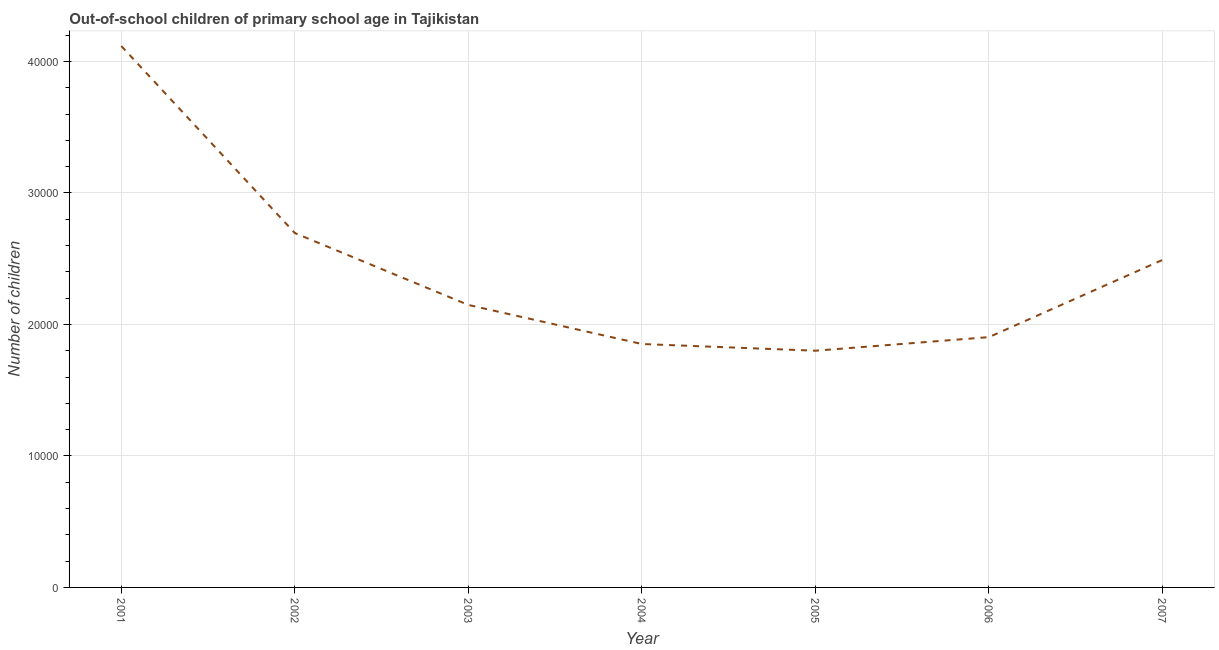What is the number of out-of-school children in 2006?
Offer a terse response. 1.90e+04. Across all years, what is the maximum number of out-of-school children?
Your response must be concise. 4.12e+04. Across all years, what is the minimum number of out-of-school children?
Your answer should be compact. 1.80e+04. In which year was the number of out-of-school children maximum?
Your answer should be compact. 2001. What is the sum of the number of out-of-school children?
Provide a succinct answer. 1.70e+05. What is the difference between the number of out-of-school children in 2005 and 2006?
Your response must be concise. -1034. What is the average number of out-of-school children per year?
Make the answer very short. 2.43e+04. What is the median number of out-of-school children?
Provide a short and direct response. 2.15e+04. In how many years, is the number of out-of-school children greater than 16000 ?
Offer a very short reply. 7. What is the ratio of the number of out-of-school children in 2001 to that in 2004?
Keep it short and to the point. 2.22. Is the difference between the number of out-of-school children in 2001 and 2002 greater than the difference between any two years?
Your answer should be very brief. No. What is the difference between the highest and the second highest number of out-of-school children?
Your answer should be compact. 1.42e+04. Is the sum of the number of out-of-school children in 2006 and 2007 greater than the maximum number of out-of-school children across all years?
Your response must be concise. Yes. What is the difference between the highest and the lowest number of out-of-school children?
Offer a very short reply. 2.32e+04. Does the number of out-of-school children monotonically increase over the years?
Provide a short and direct response. No. How many years are there in the graph?
Provide a short and direct response. 7. Are the values on the major ticks of Y-axis written in scientific E-notation?
Ensure brevity in your answer.  No. Does the graph contain grids?
Give a very brief answer. Yes. What is the title of the graph?
Keep it short and to the point. Out-of-school children of primary school age in Tajikistan. What is the label or title of the X-axis?
Offer a very short reply. Year. What is the label or title of the Y-axis?
Your response must be concise. Number of children. What is the Number of children in 2001?
Your response must be concise. 4.12e+04. What is the Number of children of 2002?
Your answer should be very brief. 2.69e+04. What is the Number of children of 2003?
Ensure brevity in your answer.  2.15e+04. What is the Number of children of 2004?
Give a very brief answer. 1.85e+04. What is the Number of children in 2005?
Your answer should be very brief. 1.80e+04. What is the Number of children of 2006?
Provide a short and direct response. 1.90e+04. What is the Number of children of 2007?
Your answer should be compact. 2.49e+04. What is the difference between the Number of children in 2001 and 2002?
Your answer should be very brief. 1.42e+04. What is the difference between the Number of children in 2001 and 2003?
Provide a succinct answer. 1.97e+04. What is the difference between the Number of children in 2001 and 2004?
Provide a succinct answer. 2.27e+04. What is the difference between the Number of children in 2001 and 2005?
Your answer should be compact. 2.32e+04. What is the difference between the Number of children in 2001 and 2006?
Offer a terse response. 2.21e+04. What is the difference between the Number of children in 2001 and 2007?
Make the answer very short. 1.63e+04. What is the difference between the Number of children in 2002 and 2003?
Offer a very short reply. 5466. What is the difference between the Number of children in 2002 and 2004?
Provide a short and direct response. 8435. What is the difference between the Number of children in 2002 and 2005?
Ensure brevity in your answer.  8945. What is the difference between the Number of children in 2002 and 2006?
Your answer should be compact. 7911. What is the difference between the Number of children in 2002 and 2007?
Your answer should be very brief. 2042. What is the difference between the Number of children in 2003 and 2004?
Your answer should be compact. 2969. What is the difference between the Number of children in 2003 and 2005?
Your response must be concise. 3479. What is the difference between the Number of children in 2003 and 2006?
Your response must be concise. 2445. What is the difference between the Number of children in 2003 and 2007?
Offer a very short reply. -3424. What is the difference between the Number of children in 2004 and 2005?
Make the answer very short. 510. What is the difference between the Number of children in 2004 and 2006?
Ensure brevity in your answer.  -524. What is the difference between the Number of children in 2004 and 2007?
Make the answer very short. -6393. What is the difference between the Number of children in 2005 and 2006?
Provide a short and direct response. -1034. What is the difference between the Number of children in 2005 and 2007?
Your answer should be very brief. -6903. What is the difference between the Number of children in 2006 and 2007?
Ensure brevity in your answer.  -5869. What is the ratio of the Number of children in 2001 to that in 2002?
Offer a very short reply. 1.53. What is the ratio of the Number of children in 2001 to that in 2003?
Provide a short and direct response. 1.92. What is the ratio of the Number of children in 2001 to that in 2004?
Keep it short and to the point. 2.22. What is the ratio of the Number of children in 2001 to that in 2005?
Provide a short and direct response. 2.29. What is the ratio of the Number of children in 2001 to that in 2006?
Provide a short and direct response. 2.16. What is the ratio of the Number of children in 2001 to that in 2007?
Your answer should be very brief. 1.65. What is the ratio of the Number of children in 2002 to that in 2003?
Your answer should be very brief. 1.25. What is the ratio of the Number of children in 2002 to that in 2004?
Your answer should be very brief. 1.46. What is the ratio of the Number of children in 2002 to that in 2005?
Offer a terse response. 1.5. What is the ratio of the Number of children in 2002 to that in 2006?
Make the answer very short. 1.42. What is the ratio of the Number of children in 2002 to that in 2007?
Offer a very short reply. 1.08. What is the ratio of the Number of children in 2003 to that in 2004?
Offer a very short reply. 1.16. What is the ratio of the Number of children in 2003 to that in 2005?
Your answer should be very brief. 1.19. What is the ratio of the Number of children in 2003 to that in 2006?
Provide a short and direct response. 1.13. What is the ratio of the Number of children in 2003 to that in 2007?
Keep it short and to the point. 0.86. What is the ratio of the Number of children in 2004 to that in 2005?
Offer a very short reply. 1.03. What is the ratio of the Number of children in 2004 to that in 2007?
Your answer should be very brief. 0.74. What is the ratio of the Number of children in 2005 to that in 2006?
Keep it short and to the point. 0.95. What is the ratio of the Number of children in 2005 to that in 2007?
Your answer should be very brief. 0.72. What is the ratio of the Number of children in 2006 to that in 2007?
Provide a short and direct response. 0.76. 